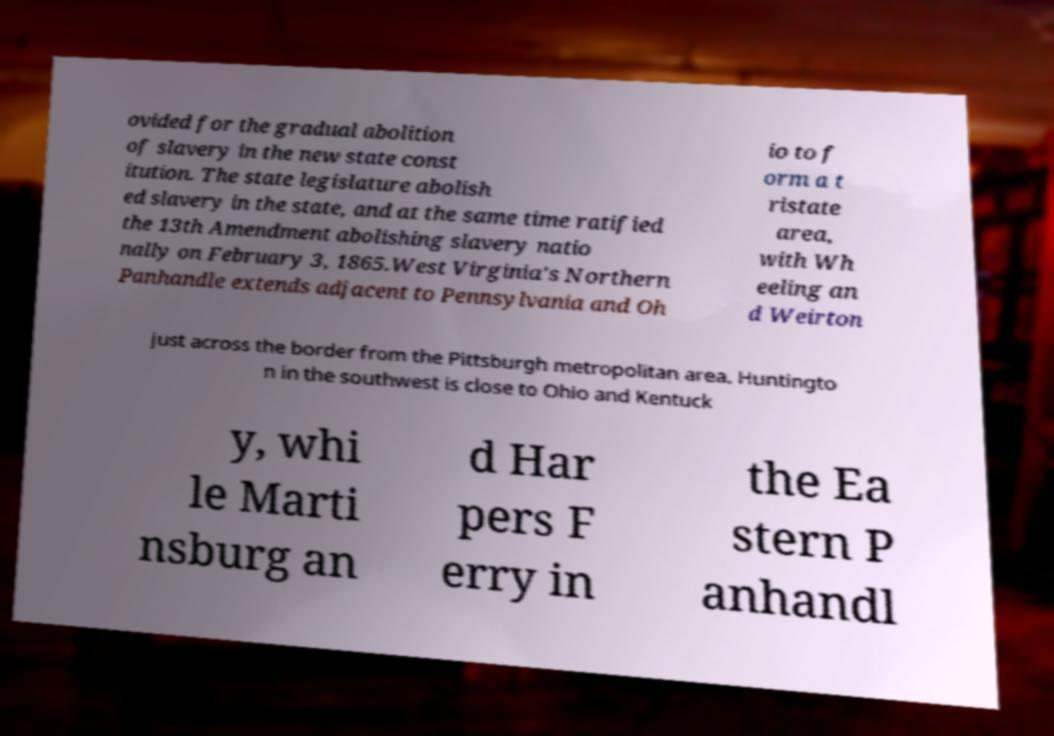Could you assist in decoding the text presented in this image and type it out clearly? ovided for the gradual abolition of slavery in the new state const itution. The state legislature abolish ed slavery in the state, and at the same time ratified the 13th Amendment abolishing slavery natio nally on February 3, 1865.West Virginia's Northern Panhandle extends adjacent to Pennsylvania and Oh io to f orm a t ristate area, with Wh eeling an d Weirton just across the border from the Pittsburgh metropolitan area. Huntingto n in the southwest is close to Ohio and Kentuck y, whi le Marti nsburg an d Har pers F erry in the Ea stern P anhandl 